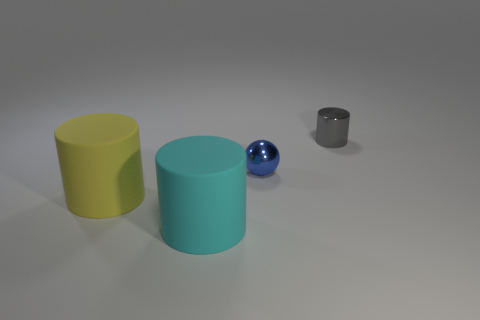Subtract all metal cylinders. How many cylinders are left? 2 Add 4 cyan things. How many objects exist? 8 Subtract all cyan cylinders. How many cylinders are left? 2 Subtract 2 cylinders. How many cylinders are left? 1 Subtract 0 purple cylinders. How many objects are left? 4 Subtract all cylinders. How many objects are left? 1 Subtract all red balls. Subtract all brown cylinders. How many balls are left? 1 Subtract all big yellow rubber balls. Subtract all small shiny cylinders. How many objects are left? 3 Add 2 small shiny balls. How many small shiny balls are left? 3 Add 3 blue metal objects. How many blue metal objects exist? 4 